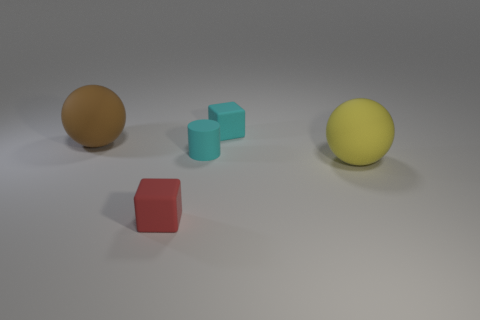Add 2 purple spheres. How many objects exist? 7 Subtract all blocks. How many objects are left? 3 Subtract 0 red balls. How many objects are left? 5 Subtract all tiny red spheres. Subtract all cyan matte cylinders. How many objects are left? 4 Add 2 large rubber objects. How many large rubber objects are left? 4 Add 3 big purple rubber balls. How many big purple rubber balls exist? 3 